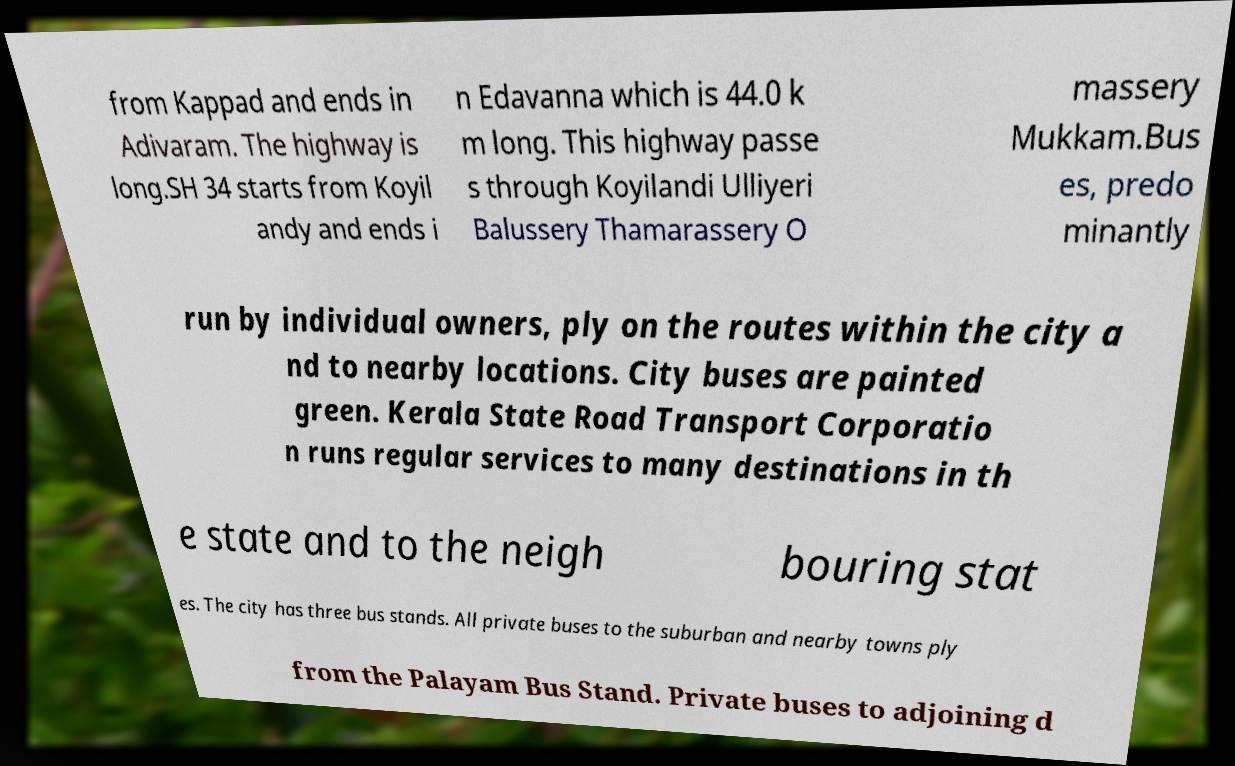Can you read and provide the text displayed in the image?This photo seems to have some interesting text. Can you extract and type it out for me? from Kappad and ends in Adivaram. The highway is long.SH 34 starts from Koyil andy and ends i n Edavanna which is 44.0 k m long. This highway passe s through Koyilandi Ulliyeri Balussery Thamarassery O massery Mukkam.Bus es, predo minantly run by individual owners, ply on the routes within the city a nd to nearby locations. City buses are painted green. Kerala State Road Transport Corporatio n runs regular services to many destinations in th e state and to the neigh bouring stat es. The city has three bus stands. All private buses to the suburban and nearby towns ply from the Palayam Bus Stand. Private buses to adjoining d 